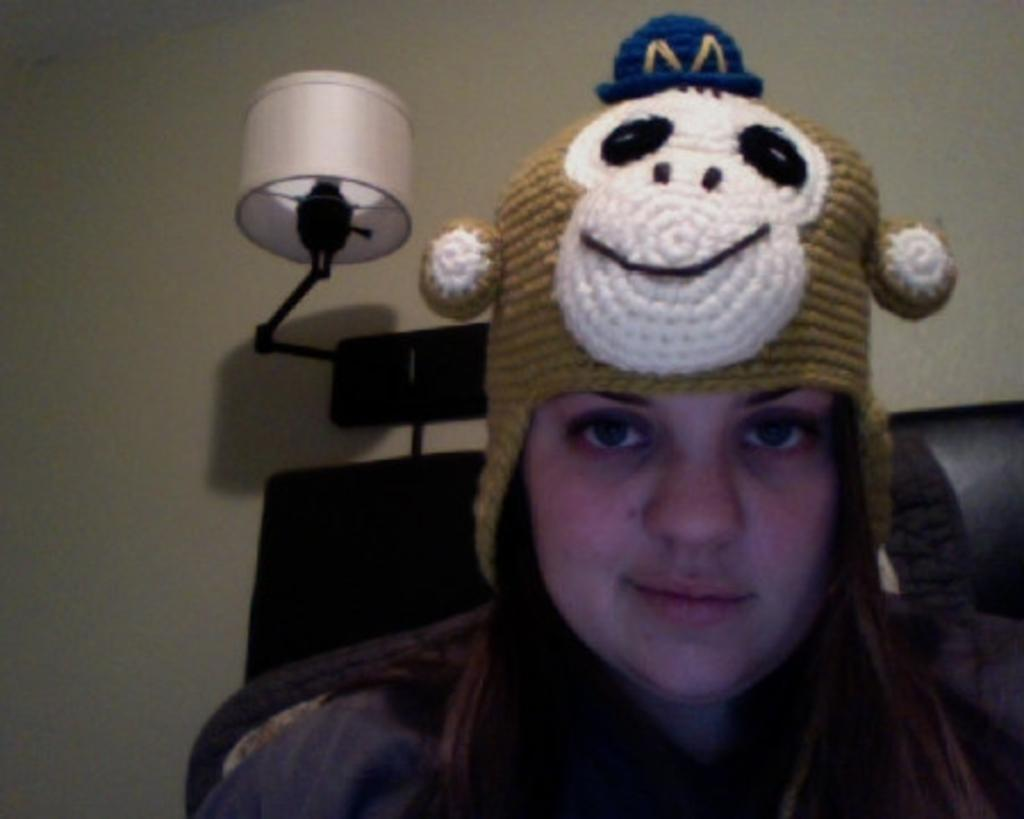Who is present in the image? There is a woman in the image. What is the woman doing in the image? The woman is looking to one side. What type of headwear is the woman wearing? The woman is wearing a monkey cap. What can be seen on the wall in the image? There is a lamp on the wall in the image. Can you tell me how many horses are in the image? There are no horses present in the image. What type of health advice is the woman giving in the image? The image does not depict the woman giving any health advice. 